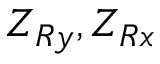<formula> <loc_0><loc_0><loc_500><loc_500>Z _ { R y } , Z _ { R x }</formula> 